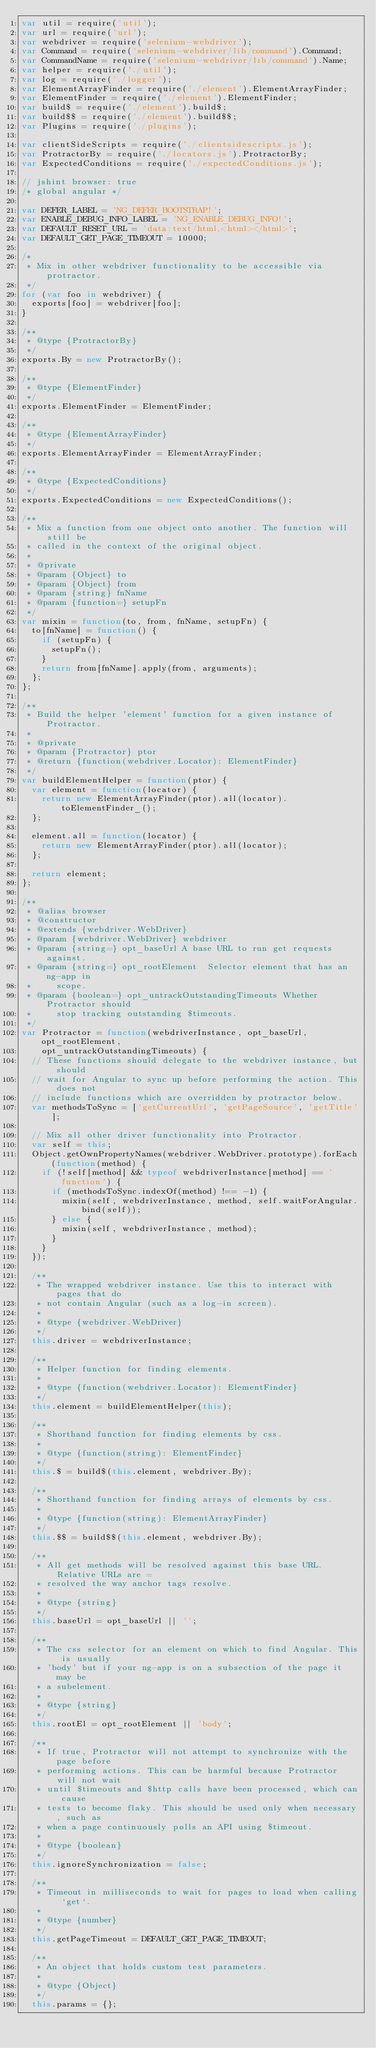<code> <loc_0><loc_0><loc_500><loc_500><_JavaScript_>var util = require('util');
var url = require('url');
var webdriver = require('selenium-webdriver');
var Command = require('selenium-webdriver/lib/command').Command;
var CommandName = require('selenium-webdriver/lib/command').Name;
var helper = require('./util');
var log = require('./logger');
var ElementArrayFinder = require('./element').ElementArrayFinder;
var ElementFinder = require('./element').ElementFinder;
var build$ = require('./element').build$;
var build$$ = require('./element').build$$;
var Plugins = require('./plugins');

var clientSideScripts = require('./clientsidescripts.js');
var ProtractorBy = require('./locators.js').ProtractorBy;
var ExpectedConditions = require('./expectedConditions.js');

// jshint browser: true
/* global angular */

var DEFER_LABEL = 'NG_DEFER_BOOTSTRAP!';
var ENABLE_DEBUG_INFO_LABEL = 'NG_ENABLE_DEBUG_INFO!';
var DEFAULT_RESET_URL = 'data:text/html,<html></html>';
var DEFAULT_GET_PAGE_TIMEOUT = 10000;

/*
 * Mix in other webdriver functionality to be accessible via protractor.
 */
for (var foo in webdriver) {
  exports[foo] = webdriver[foo];
}

/**
 * @type {ProtractorBy}
 */
exports.By = new ProtractorBy();

/**
 * @type {ElementFinder}
 */
exports.ElementFinder = ElementFinder;

/**
 * @type {ElementArrayFinder}
 */
exports.ElementArrayFinder = ElementArrayFinder;

/**
 * @type {ExpectedConditions}
 */
exports.ExpectedConditions = new ExpectedConditions();

/**
 * Mix a function from one object onto another. The function will still be
 * called in the context of the original object.
 *
 * @private
 * @param {Object} to
 * @param {Object} from
 * @param {string} fnName
 * @param {function=} setupFn
 */
var mixin = function(to, from, fnName, setupFn) {
  to[fnName] = function() {
    if (setupFn) {
      setupFn();
    }
    return from[fnName].apply(from, arguments);
  };
};

/**
 * Build the helper 'element' function for a given instance of Protractor.
 *
 * @private
 * @param {Protractor} ptor
 * @return {function(webdriver.Locator): ElementFinder}
 */
var buildElementHelper = function(ptor) {
  var element = function(locator) {
    return new ElementArrayFinder(ptor).all(locator).toElementFinder_();
  };

  element.all = function(locator) {
    return new ElementArrayFinder(ptor).all(locator);
  };

  return element;
};

/**
 * @alias browser
 * @constructor
 * @extends {webdriver.WebDriver}
 * @param {webdriver.WebDriver} webdriver
 * @param {string=} opt_baseUrl A base URL to run get requests against.
 * @param {string=} opt_rootElement  Selector element that has an ng-app in
 *     scope.
 * @param {boolean=} opt_untrackOutstandingTimeouts Whether Protractor should 
 *     stop tracking outstanding $timeouts.
 */
var Protractor = function(webdriverInstance, opt_baseUrl, opt_rootElement, 
    opt_untrackOutstandingTimeouts) {
  // These functions should delegate to the webdriver instance, but should
  // wait for Angular to sync up before performing the action. This does not
  // include functions which are overridden by protractor below.
  var methodsToSync = ['getCurrentUrl', 'getPageSource', 'getTitle'];

  // Mix all other driver functionality into Protractor.
  var self = this;
  Object.getOwnPropertyNames(webdriver.WebDriver.prototype).forEach(function(method) {
    if (!self[method] && typeof webdriverInstance[method] == 'function') {
      if (methodsToSync.indexOf(method) !== -1) {
        mixin(self, webdriverInstance, method, self.waitForAngular.bind(self));
      } else {
        mixin(self, webdriverInstance, method);
      }
    }
  });

  /**
   * The wrapped webdriver instance. Use this to interact with pages that do
   * not contain Angular (such as a log-in screen).
   *
   * @type {webdriver.WebDriver}
   */
  this.driver = webdriverInstance;

  /**
   * Helper function for finding elements.
   *
   * @type {function(webdriver.Locator): ElementFinder}
   */
  this.element = buildElementHelper(this);

  /**
   * Shorthand function for finding elements by css.
   *
   * @type {function(string): ElementFinder}
   */
  this.$ = build$(this.element, webdriver.By);

  /**
   * Shorthand function for finding arrays of elements by css.
   *
   * @type {function(string): ElementArrayFinder}
   */
  this.$$ = build$$(this.element, webdriver.By);

  /**
   * All get methods will be resolved against this base URL. Relative URLs are =
   * resolved the way anchor tags resolve.
   *
   * @type {string}
   */
  this.baseUrl = opt_baseUrl || '';

  /**
   * The css selector for an element on which to find Angular. This is usually
   * 'body' but if your ng-app is on a subsection of the page it may be
   * a subelement.
   *
   * @type {string}
   */
  this.rootEl = opt_rootElement || 'body';

  /**
   * If true, Protractor will not attempt to synchronize with the page before
   * performing actions. This can be harmful because Protractor will not wait
   * until $timeouts and $http calls have been processed, which can cause
   * tests to become flaky. This should be used only when necessary, such as
   * when a page continuously polls an API using $timeout.
   *
   * @type {boolean}
   */
  this.ignoreSynchronization = false;

  /**
   * Timeout in milliseconds to wait for pages to load when calling `get`.
   *
   * @type {number}
   */
  this.getPageTimeout = DEFAULT_GET_PAGE_TIMEOUT;

  /**
   * An object that holds custom test parameters.
   *
   * @type {Object}
   */
  this.params = {};
</code> 